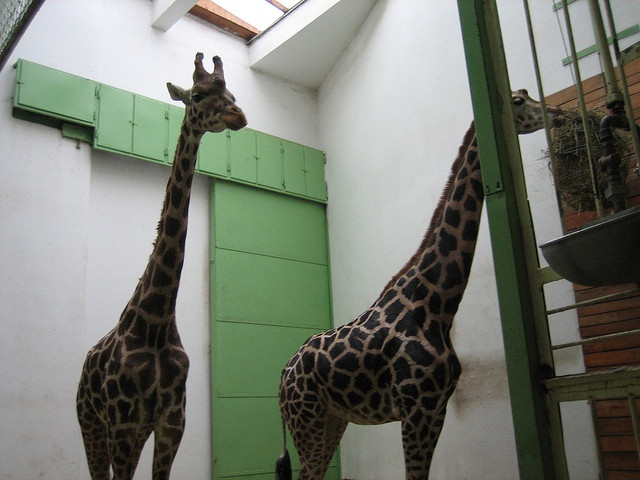Describe the objects in this image and their specific colors. I can see giraffe in gray and black tones, giraffe in gray and black tones, and sink in gray, black, and darkgray tones in this image. 